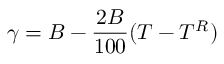<formula> <loc_0><loc_0><loc_500><loc_500>\gamma = B - { \frac { 2 B } { 1 0 0 } } ( T - T ^ { R } )</formula> 